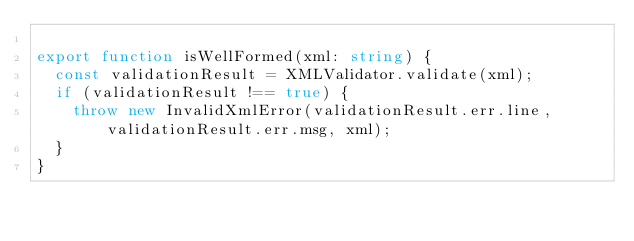<code> <loc_0><loc_0><loc_500><loc_500><_TypeScript_>
export function isWellFormed(xml: string) {
  const validationResult = XMLValidator.validate(xml);
  if (validationResult !== true) {
    throw new InvalidXmlError(validationResult.err.line, validationResult.err.msg, xml);
  }
}
</code> 